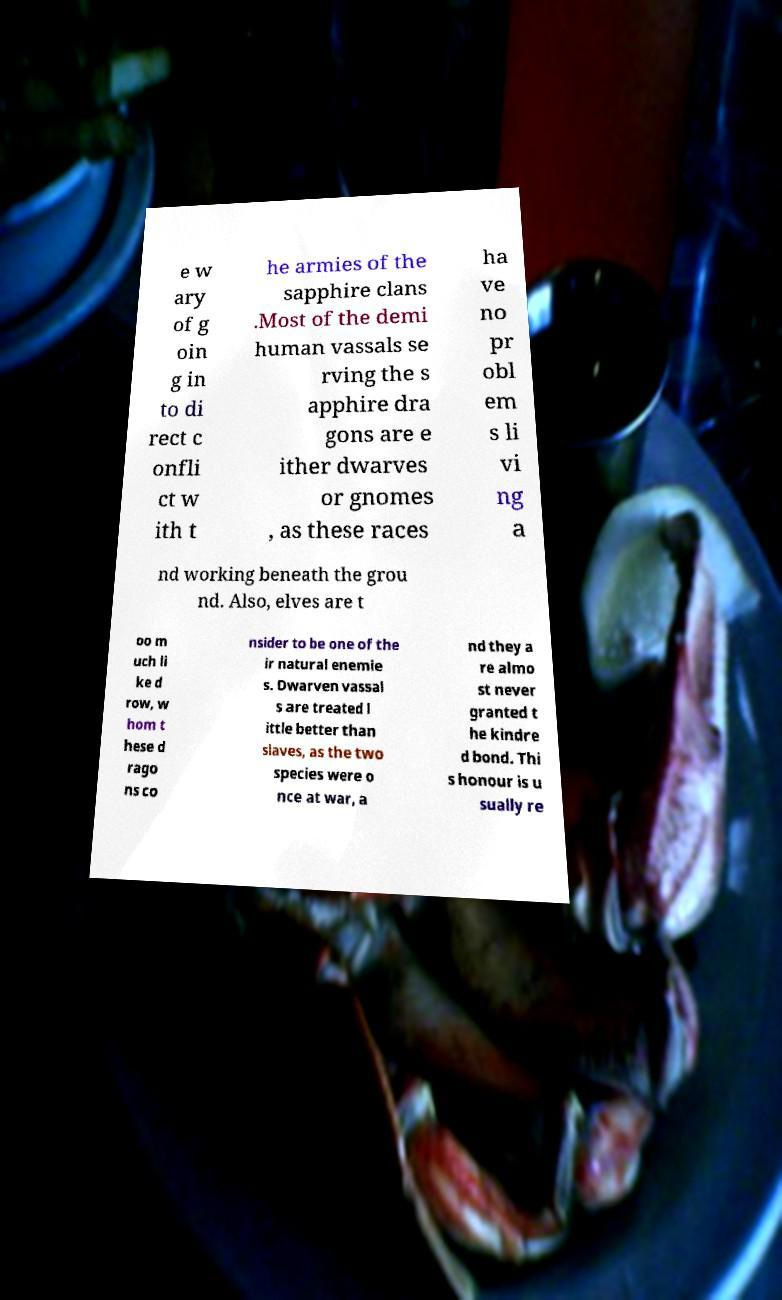Can you read and provide the text displayed in the image?This photo seems to have some interesting text. Can you extract and type it out for me? e w ary of g oin g in to di rect c onfli ct w ith t he armies of the sapphire clans .Most of the demi human vassals se rving the s apphire dra gons are e ither dwarves or gnomes , as these races ha ve no pr obl em s li vi ng a nd working beneath the grou nd. Also, elves are t oo m uch li ke d row, w hom t hese d rago ns co nsider to be one of the ir natural enemie s. Dwarven vassal s are treated l ittle better than slaves, as the two species were o nce at war, a nd they a re almo st never granted t he kindre d bond. Thi s honour is u sually re 